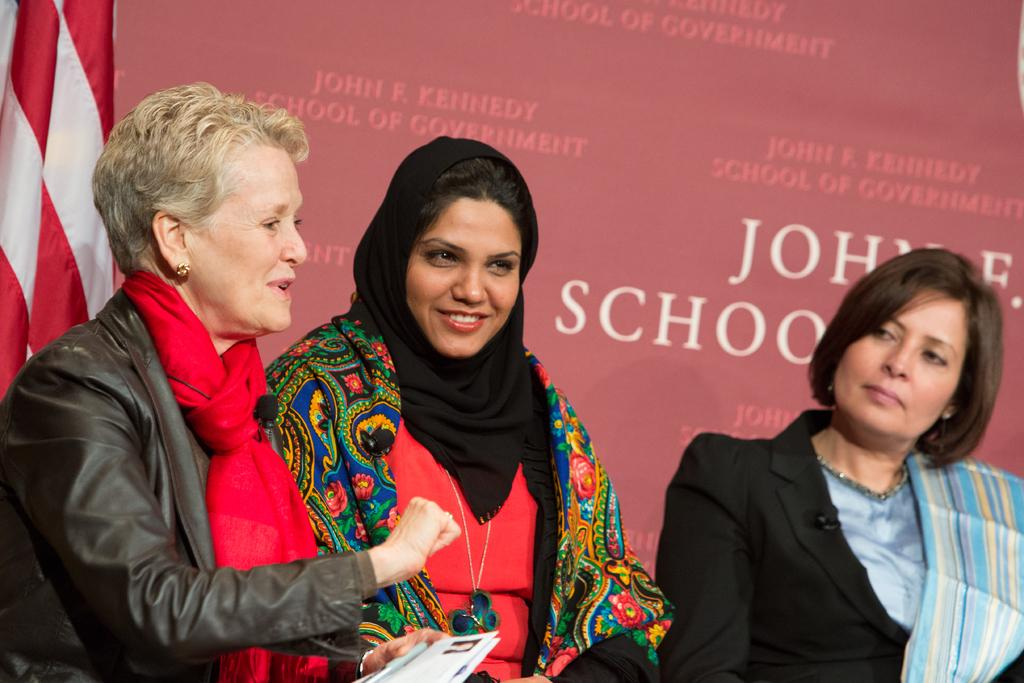How many women are in the front of the image? There are three women in the front of the image. What are the women on the left side wearing? The two women on the left side are wearing scarves. What can be seen on the left side of the image? There is a cloth on the left side of the image. What is visible in the background of the image? There is some text visible in the background of the image. What type of bubble is being blown by the woman on the right side of the image? There is no bubble present in the image; it only features three women, two of whom are wearing scarves, and a cloth on the left side. 